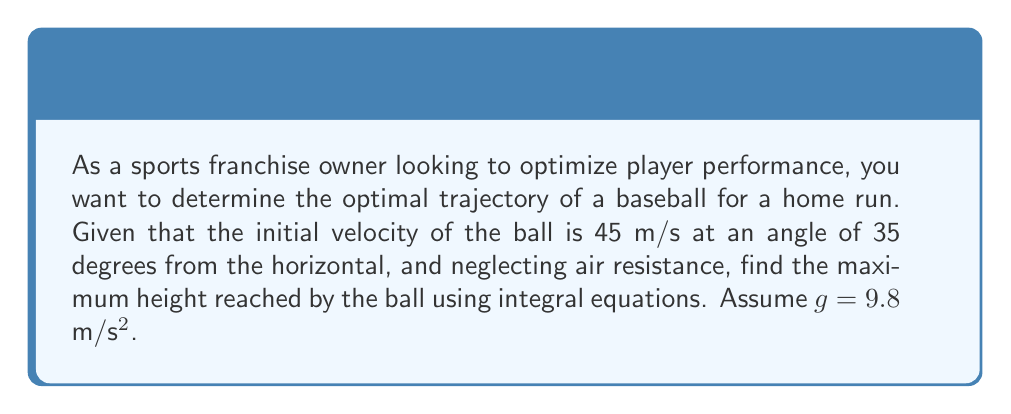Solve this math problem. To solve this problem, we'll use integral equations to determine the optimal trajectory:

1. First, we need to break down the initial velocity into horizontal and vertical components:
   $v_x = v \cos \theta = 45 \cos 35° = 36.87$ m/s
   $v_y = v \sin \theta = 45 \sin 35° = 25.80$ m/s

2. The vertical velocity as a function of time is given by:
   $v_y(t) = v_y - gt$

3. To find the height as a function of time, we integrate $v_y(t)$:
   $$y(t) = \int v_y(t) dt = \int (v_y - gt) dt = v_y t - \frac{1}{2}gt^2 + C$$

4. The constant C is 0 since the initial height is 0.

5. The maximum height is reached when the vertical velocity is 0:
   $0 = v_y - gt_{\text{max}}$
   $t_{\text{max}} = \frac{v_y}{g} = \frac{25.80}{9.8} = 2.63$ s

6. Substitute this time into the height equation:
   $$y_{\text{max}} = v_y t_{\text{max}} - \frac{1}{2}g(t_{\text{max}})^2$$
   $$y_{\text{max}} = 25.80 \cdot 2.63 - \frac{1}{2} \cdot 9.8 \cdot (2.63)^2$$
   $$y_{\text{max}} = 67.85 - 33.93 = 33.92$ m$$

Therefore, the maximum height reached by the ball is approximately 33.92 meters.
Answer: 33.92 m 